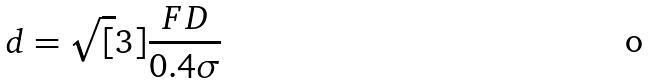Convert formula to latex. <formula><loc_0><loc_0><loc_500><loc_500>d = \sqrt { [ } 3 ] { \frac { F D } { 0 . 4 \sigma } }</formula> 